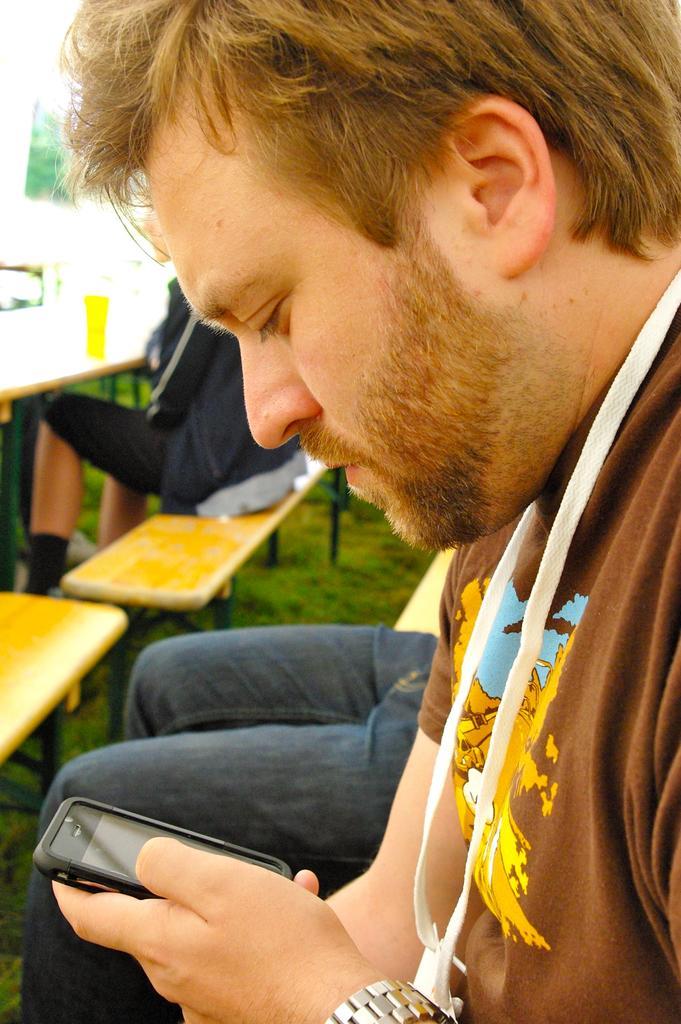How would you summarize this image in a sentence or two? On the right side, there is a person in a brown color T-shirt, wearing a badge, sitting and holding a mobile. Beside him, there is another person sitting. On the left side, there is a table, on which there are some objects. Beside this table, there is a person sitting on a bench. Beside this bench, there is another bench on the ground, on which there is grass. In the background, there a tree. 